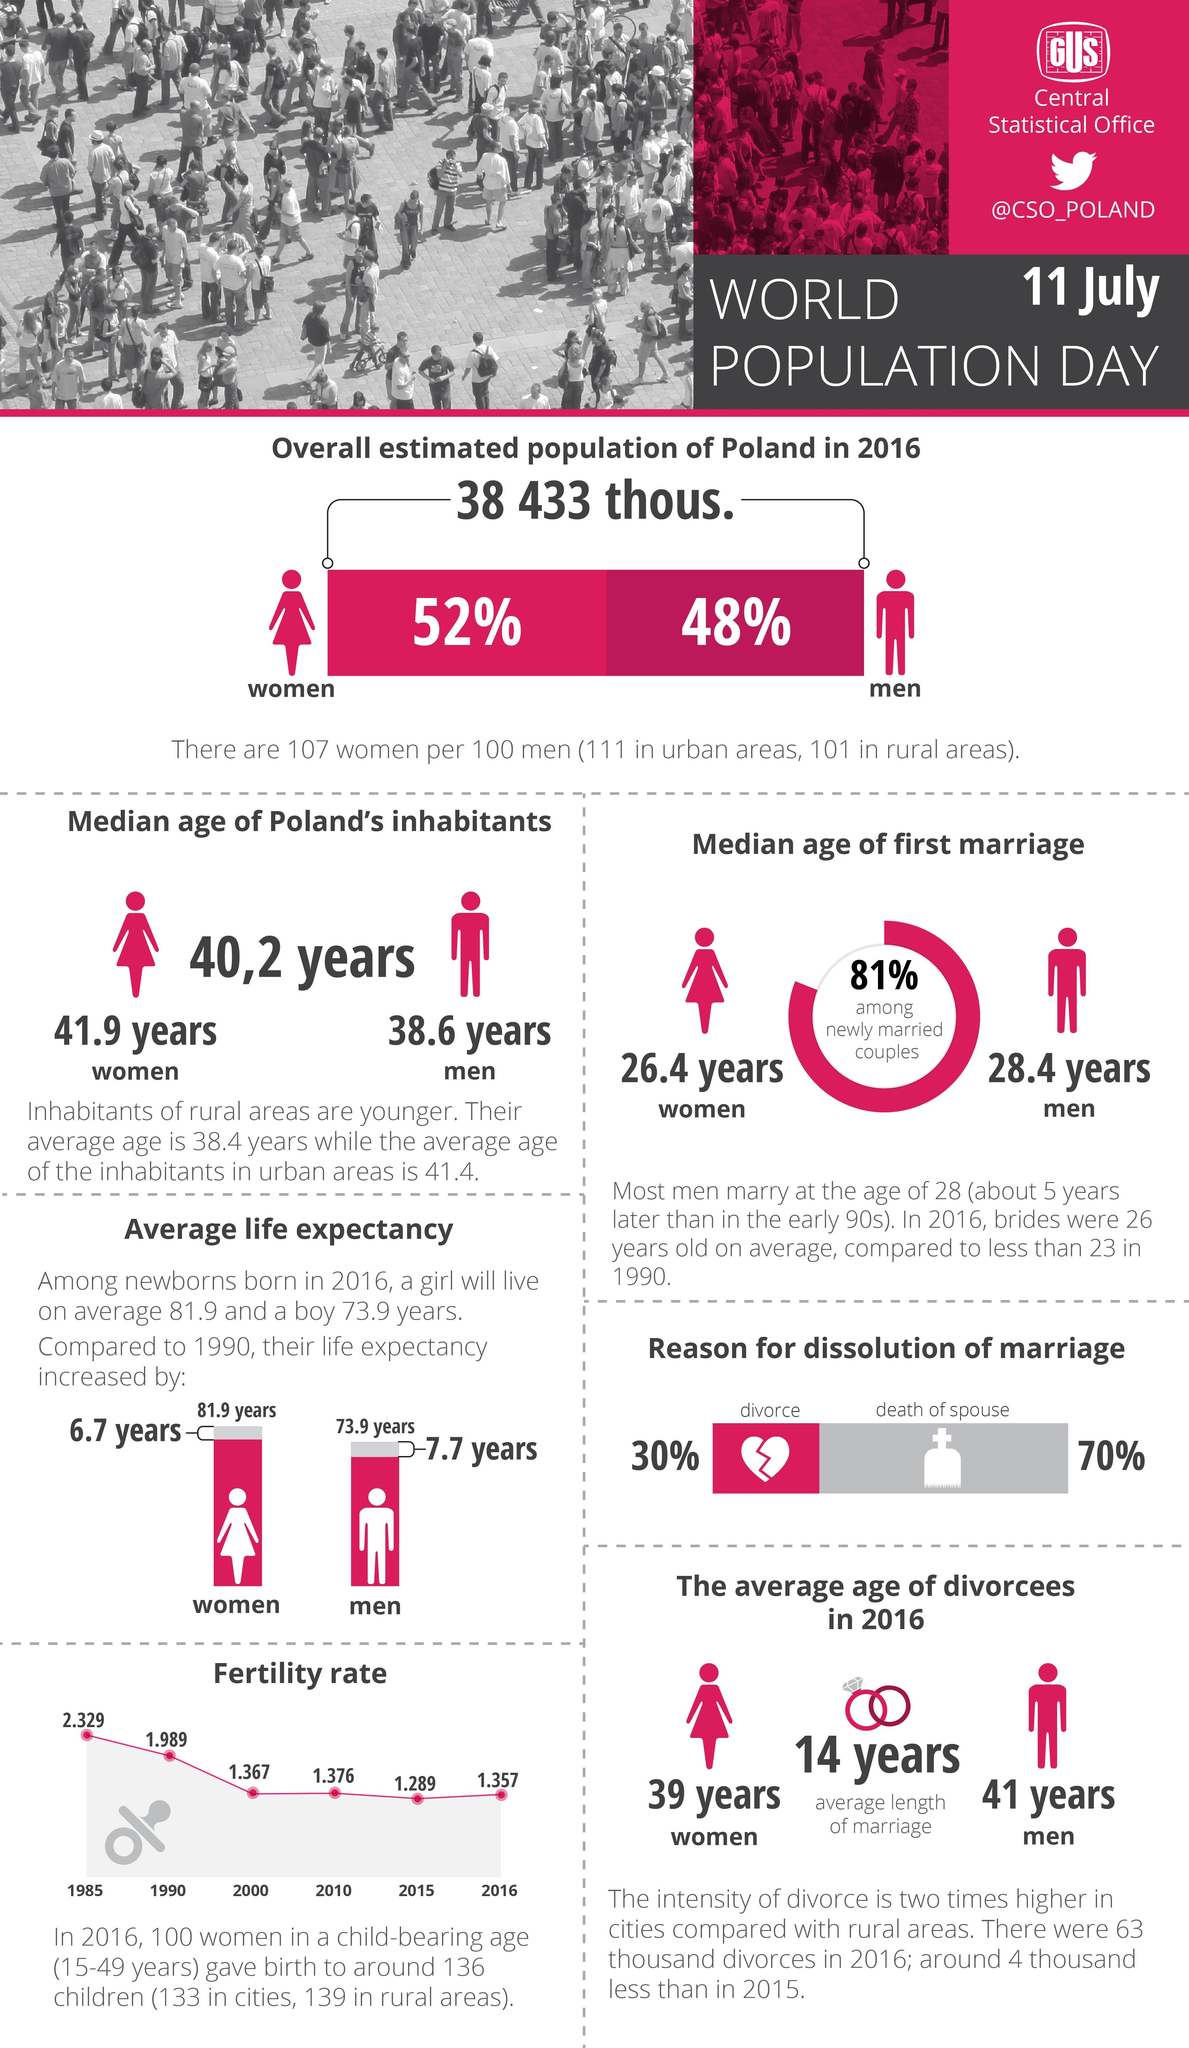Mention a couple of crucial points in this snapshot. The life expectancy of a boy born in 1990 is 66.2 years, according to data. In 2000 and 2010, the fertility rate taken together was 2.743 The fertility rate in 1985 and 1990, taken together, was 4.318... The life expectancy of a girl born in 1990 is 75.2 years, according to data. 